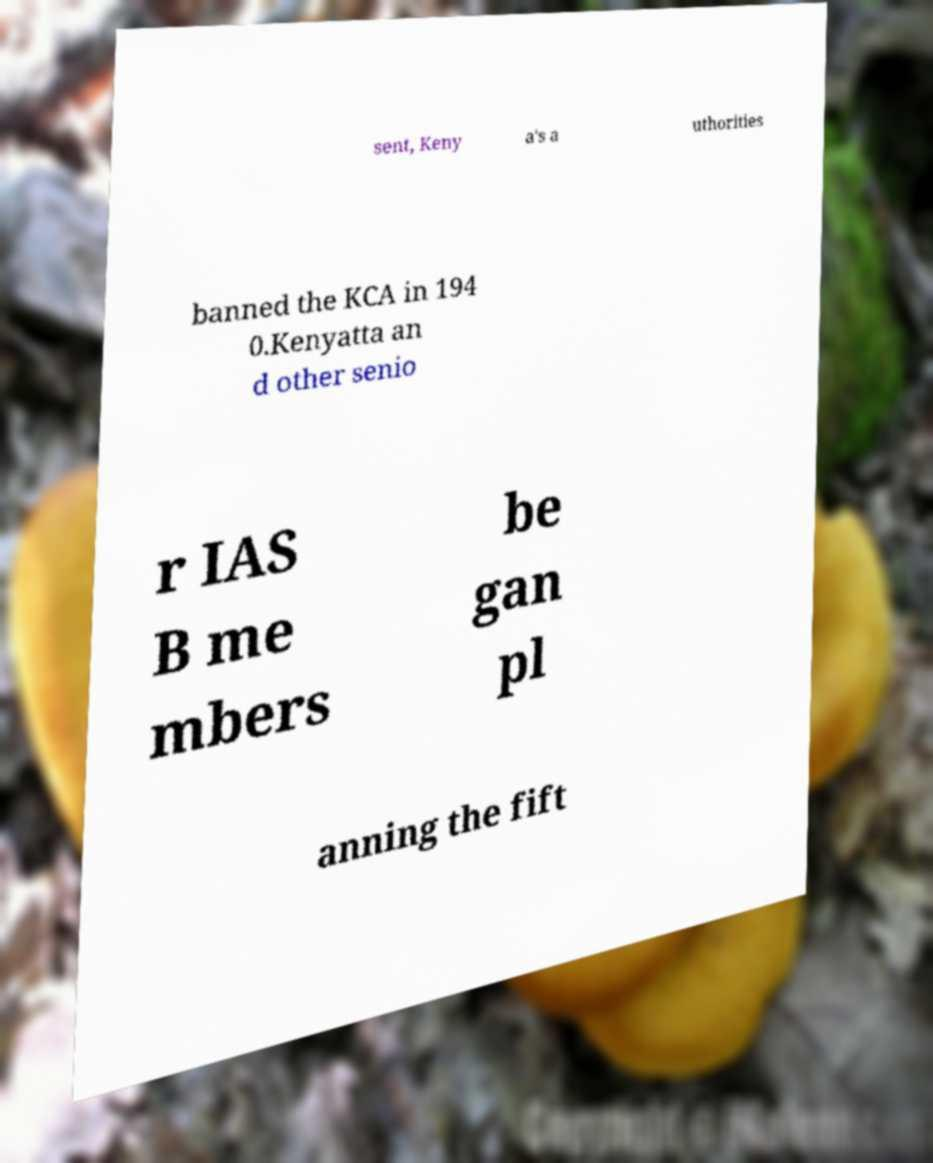Could you extract and type out the text from this image? sent, Keny a's a uthorities banned the KCA in 194 0.Kenyatta an d other senio r IAS B me mbers be gan pl anning the fift 